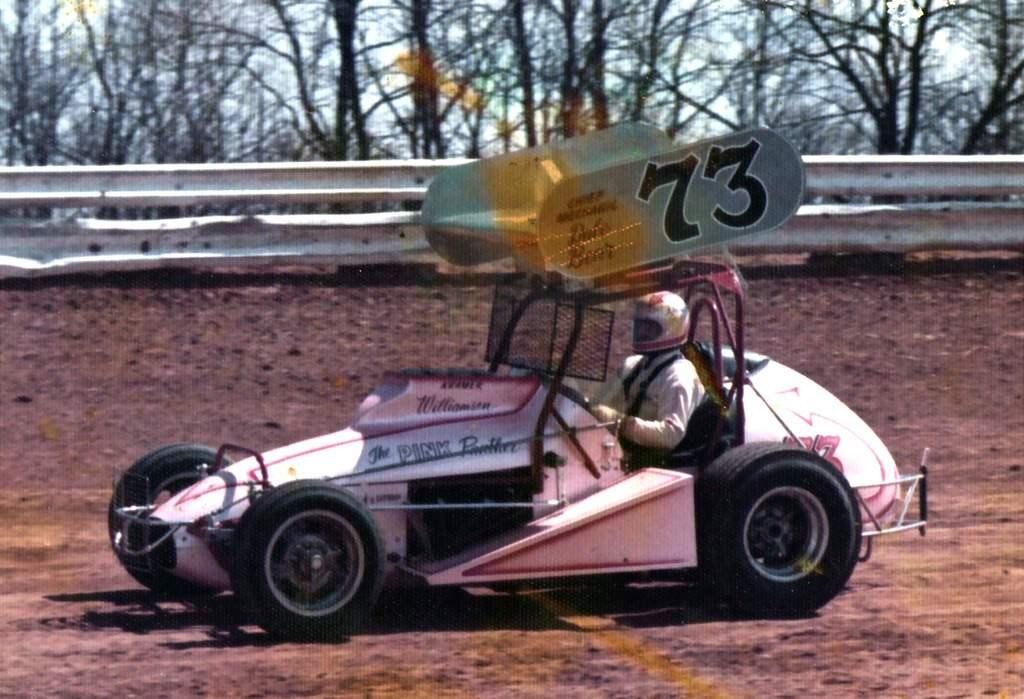<image>
Present a compact description of the photo's key features. A small race car that looks hand-built has the number 73 and sits on a dirt track. 